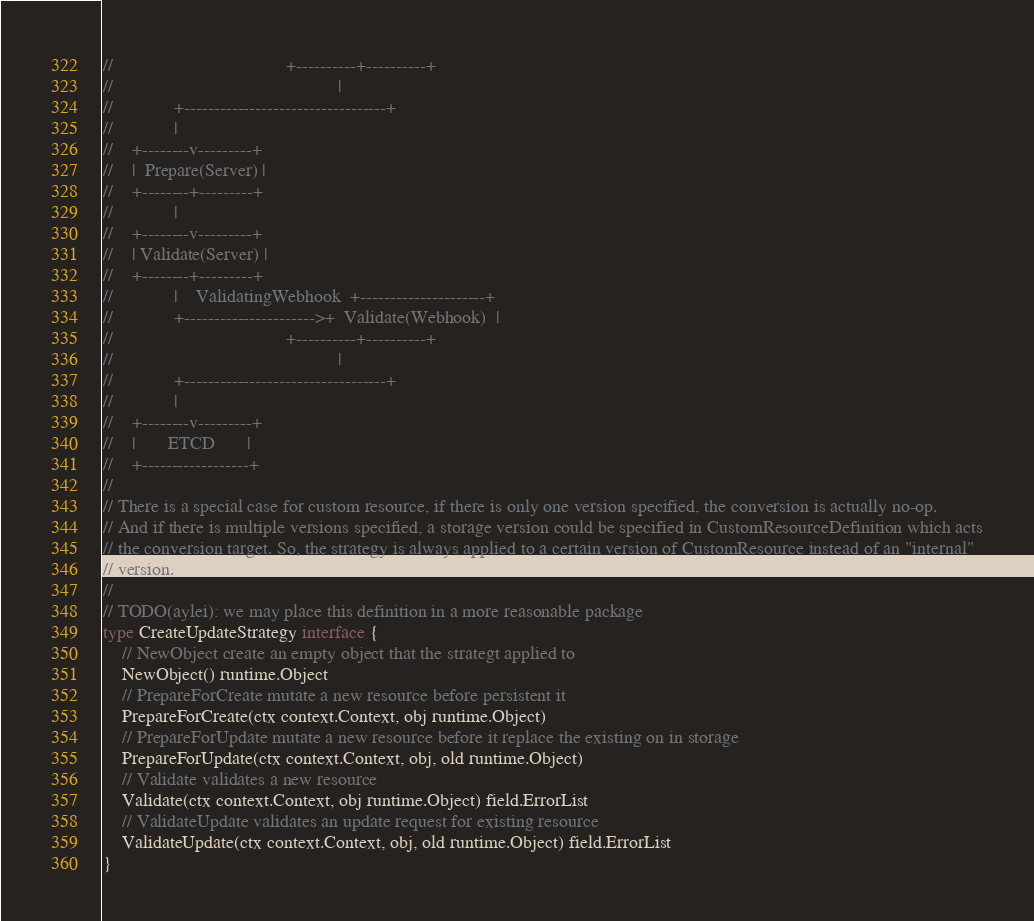Convert code to text. <code><loc_0><loc_0><loc_500><loc_500><_Go_>//                                     +----------+----------+
//                                                |
//             +----------------------------------+
//             |
//    +--------v---------+
//    |  Prepare(Server) |
//    +--------+---------+
//             |
//    +--------v---------+
//    | Validate(Server) |
//    +--------+---------+
//             |    ValidatingWebhook  +---------------------+
//             +---------------------->+  Validate(Webhook)  |
//                                     +----------+----------+
//                                                |
//             +----------------------------------+
//             |
//    +--------v---------+
//    |       ETCD       |
//    +------------------+
//
// There is a special case for custom resource, if there is only one version specified, the conversion is actually no-op.
// And if there is multiple versions specified, a storage version could be specified in CustomResourceDefinition which acts
// the conversion target. So, the strategy is always applied to a certain version of CustomResource instead of an "internal"
// version.
//
// TODO(aylei): we may place this definition in a more reasonable package
type CreateUpdateStrategy interface {
	// NewObject create an empty object that the strategt applied to
	NewObject() runtime.Object
	// PrepareForCreate mutate a new resource before persistent it
	PrepareForCreate(ctx context.Context, obj runtime.Object)
	// PrepareForUpdate mutate a new resource before it replace the existing on in storage
	PrepareForUpdate(ctx context.Context, obj, old runtime.Object)
	// Validate validates a new resource
	Validate(ctx context.Context, obj runtime.Object) field.ErrorList
	// ValidateUpdate validates an update request for existing resource
	ValidateUpdate(ctx context.Context, obj, old runtime.Object) field.ErrorList
}
</code> 